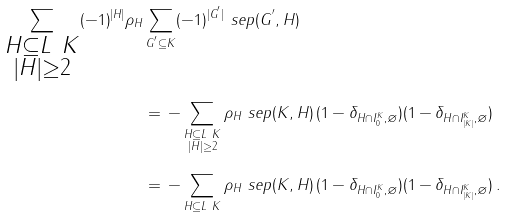<formula> <loc_0><loc_0><loc_500><loc_500>\sum _ { \substack { H \subseteq L \ K \\ | H | \geq 2 } } ( - 1 ) ^ { | H | } \rho _ { H } & \sum _ { G ^ { ^ { \prime } } \subseteq K } ( - 1 ) ^ { | G ^ { ^ { \prime } } | } \ s e p ( G ^ { ^ { \prime } } , H ) \\ & = \, - \sum _ { \substack { H \subseteq L \ K \\ | H | \geq 2 } } \rho _ { H } \ s e p ( K , H ) \, ( 1 - \delta _ { H \cap I _ { 0 } ^ { K } , \varnothing } ) ( 1 - \delta _ { H \cap I _ { | K | } ^ { K } , \varnothing } ) \\ & = \, - \sum _ { H \subseteq L \ K } \rho _ { H } \ s e p ( K , H ) \, ( 1 - \delta _ { H \cap I _ { 0 } ^ { K } , \varnothing } ) ( 1 - \delta _ { H \cap I _ { | K | } ^ { K } , \varnothing } ) \, .</formula> 